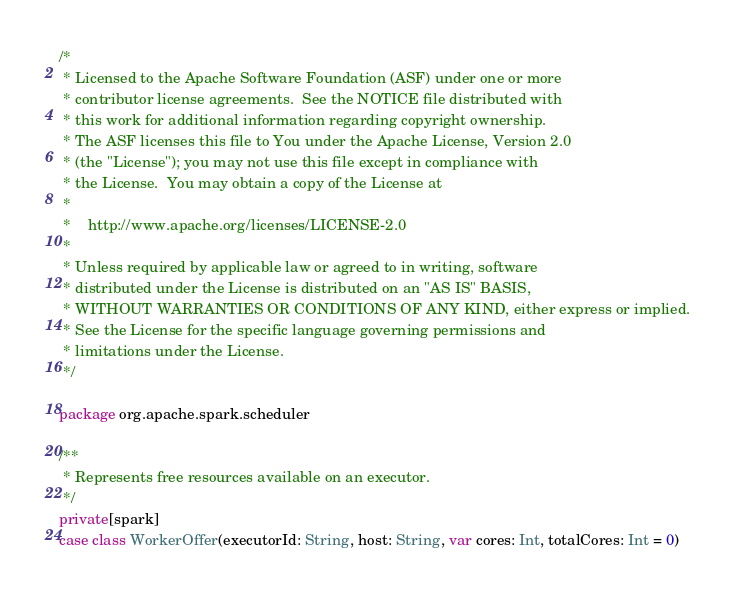<code> <loc_0><loc_0><loc_500><loc_500><_Scala_>/*
 * Licensed to the Apache Software Foundation (ASF) under one or more
 * contributor license agreements.  See the NOTICE file distributed with
 * this work for additional information regarding copyright ownership.
 * The ASF licenses this file to You under the Apache License, Version 2.0
 * (the "License"); you may not use this file except in compliance with
 * the License.  You may obtain a copy of the License at
 *
 *    http://www.apache.org/licenses/LICENSE-2.0
 *
 * Unless required by applicable law or agreed to in writing, software
 * distributed under the License is distributed on an "AS IS" BASIS,
 * WITHOUT WARRANTIES OR CONDITIONS OF ANY KIND, either express or implied.
 * See the License for the specific language governing permissions and
 * limitations under the License.
 */

package org.apache.spark.scheduler

/**
 * Represents free resources available on an executor.
 */
private[spark]
case class WorkerOffer(executorId: String, host: String, var cores: Int, totalCores: Int = 0)
</code> 